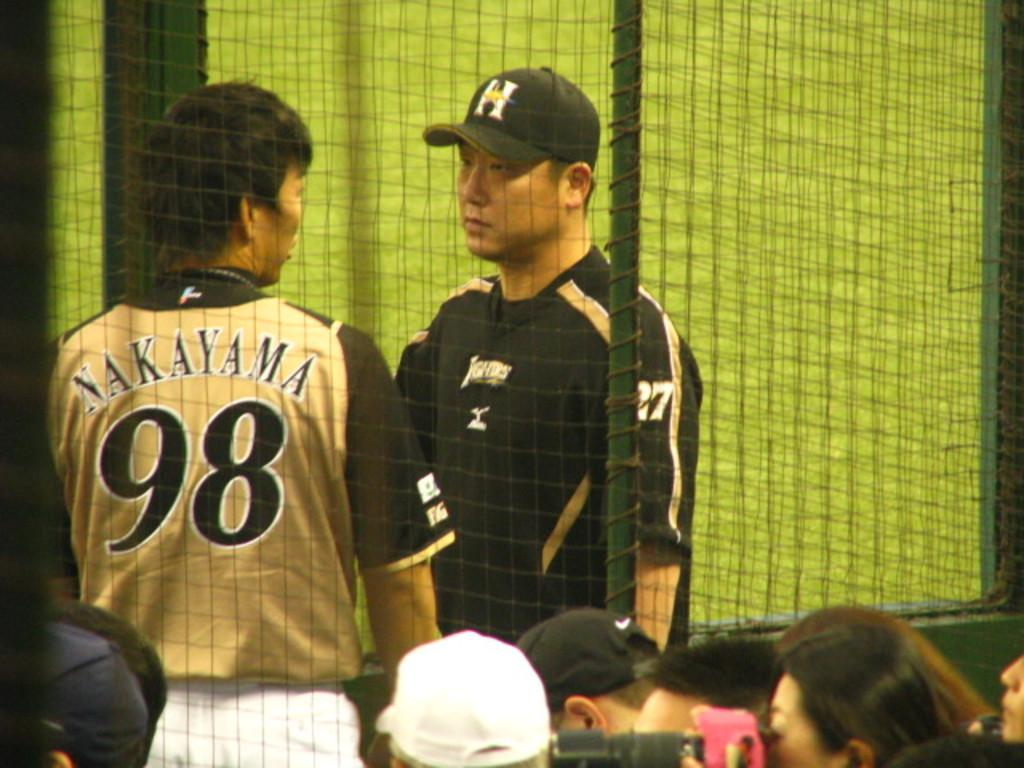<image>
Relay a brief, clear account of the picture shown. Nakayama wears number 98 for his sports team. 